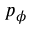<formula> <loc_0><loc_0><loc_500><loc_500>p _ { \phi }</formula> 